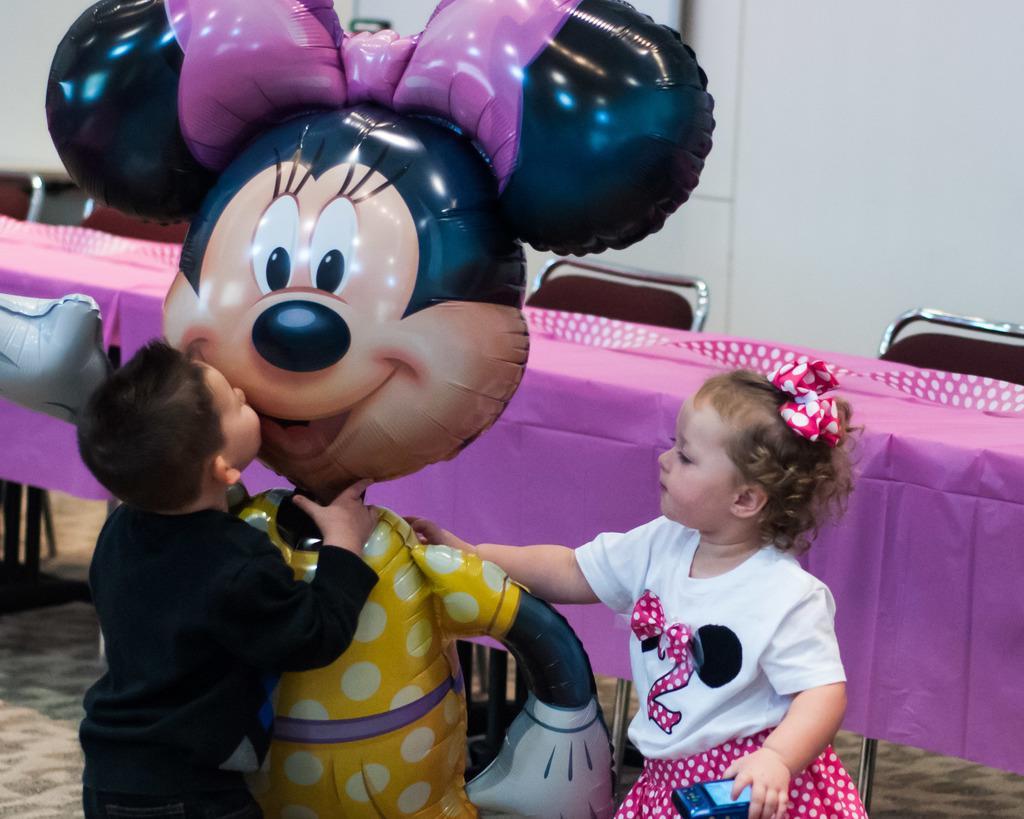In one or two sentences, can you explain what this image depicts? In this picture we can see two kids, toy on the ground and in the background we can see a platform, chairs, wall. 